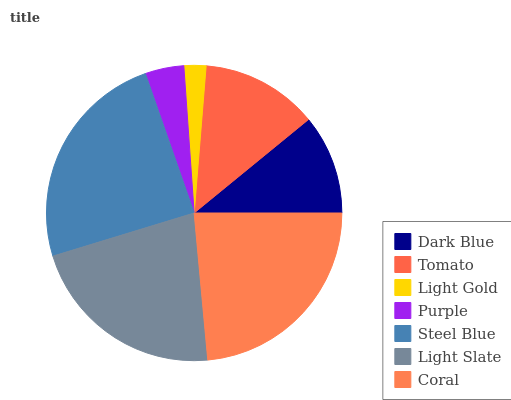Is Light Gold the minimum?
Answer yes or no. Yes. Is Steel Blue the maximum?
Answer yes or no. Yes. Is Tomato the minimum?
Answer yes or no. No. Is Tomato the maximum?
Answer yes or no. No. Is Tomato greater than Dark Blue?
Answer yes or no. Yes. Is Dark Blue less than Tomato?
Answer yes or no. Yes. Is Dark Blue greater than Tomato?
Answer yes or no. No. Is Tomato less than Dark Blue?
Answer yes or no. No. Is Tomato the high median?
Answer yes or no. Yes. Is Tomato the low median?
Answer yes or no. Yes. Is Coral the high median?
Answer yes or no. No. Is Purple the low median?
Answer yes or no. No. 